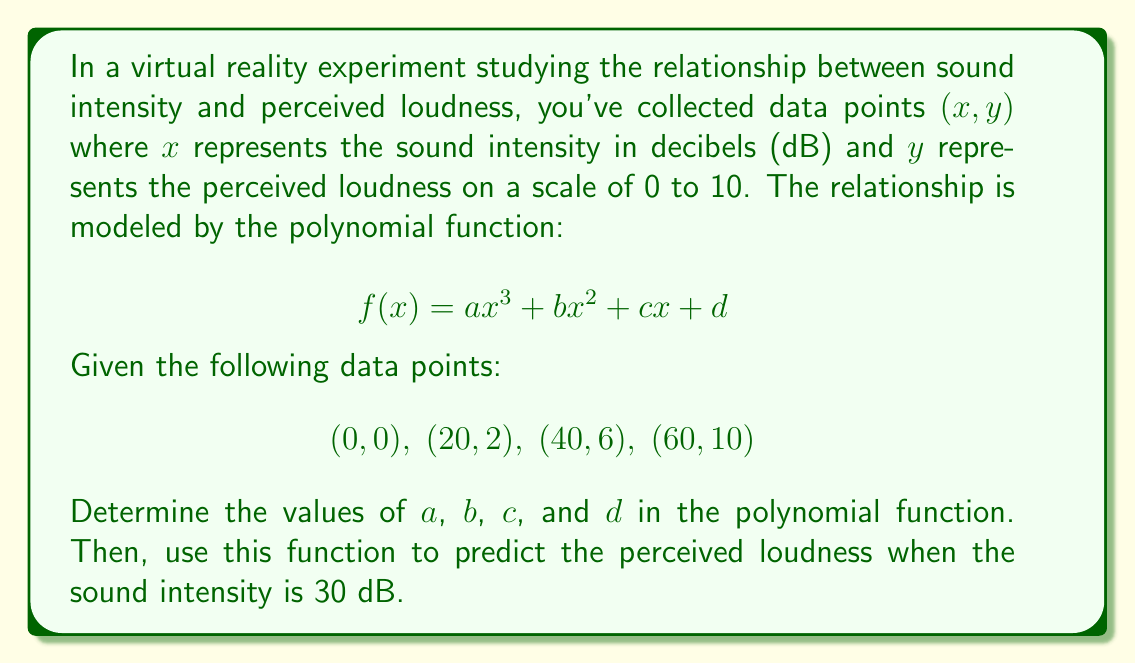Can you answer this question? To solve this problem, we'll follow these steps:

1) We have four data points, so we can create a system of four equations:

   $$0 = d$$
   $$2 = 8000a + 400b + 20c + d$$
   $$6 = 64000a + 1600b + 40c + d$$
   $$10 = 216000a + 3600b + 60c + d$$

2) From the first equation, we know that $d = 0$. Substituting this into the other equations:

   $$2 = 8000a + 400b + 20c$$
   $$6 = 64000a + 1600b + 40c$$
   $$10 = 216000a + 3600b + 60c$$

3) We can solve this system of equations using elimination or matrix methods. After solving, we get:

   $$a = \frac{1}{24000}, b = -\frac{1}{400}, c = \frac{1}{4}$$

4) Therefore, our polynomial function is:

   $$f(x) = \frac{1}{24000}x^3 - \frac{1}{400}x^2 + \frac{1}{4}x$$

5) To predict the perceived loudness when the sound intensity is 30 dB, we substitute $x = 30$ into our function:

   $$f(30) = \frac{1}{24000}(30^3) - \frac{1}{400}(30^2) + \frac{1}{4}(30)$$
   
   $$= \frac{27000}{24000} - \frac{900}{400} + \frac{30}{4}$$
   
   $$= 1.125 - 2.25 + 7.5 = 6.375$$

Therefore, the predicted perceived loudness when the sound intensity is 30 dB is approximately 6.375 on the 0-10 scale.
Answer: The polynomial function is $f(x) = \frac{1}{24000}x^3 - \frac{1}{400}x^2 + \frac{1}{4}x$, and the predicted perceived loudness at 30 dB is approximately 6.375. 